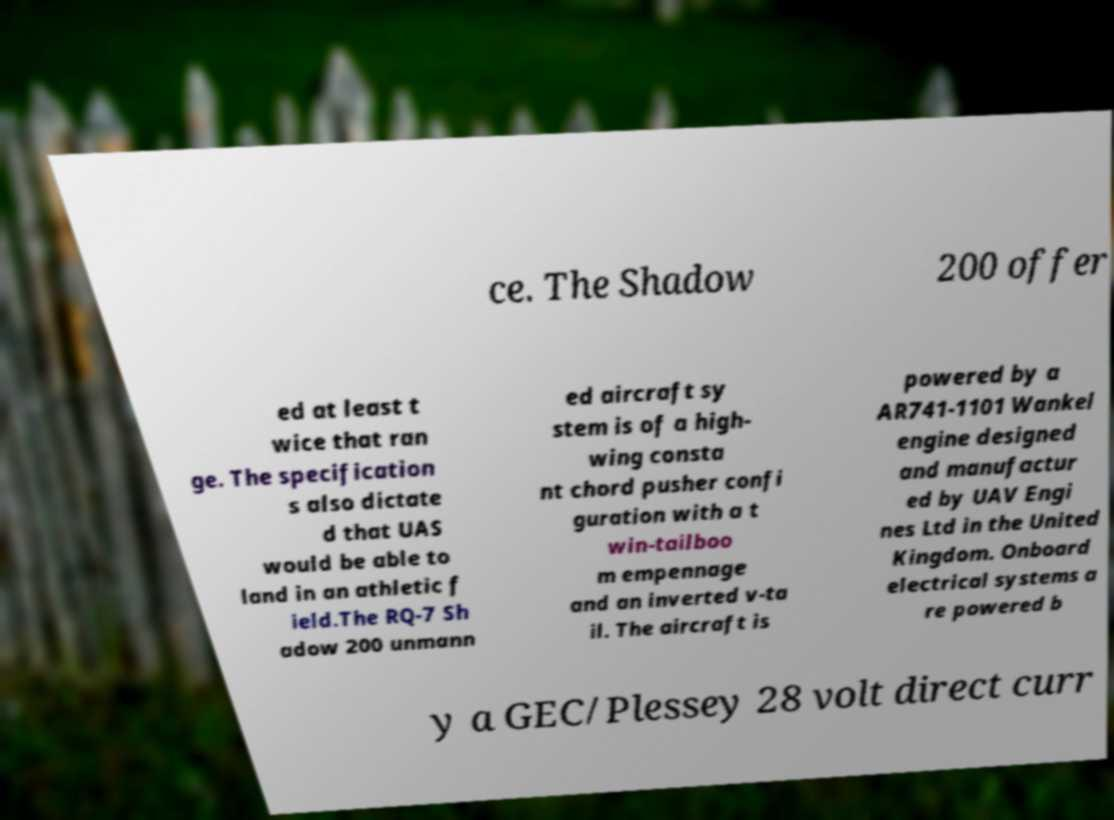Could you extract and type out the text from this image? ce. The Shadow 200 offer ed at least t wice that ran ge. The specification s also dictate d that UAS would be able to land in an athletic f ield.The RQ-7 Sh adow 200 unmann ed aircraft sy stem is of a high- wing consta nt chord pusher confi guration with a t win-tailboo m empennage and an inverted v-ta il. The aircraft is powered by a AR741-1101 Wankel engine designed and manufactur ed by UAV Engi nes Ltd in the United Kingdom. Onboard electrical systems a re powered b y a GEC/Plessey 28 volt direct curr 